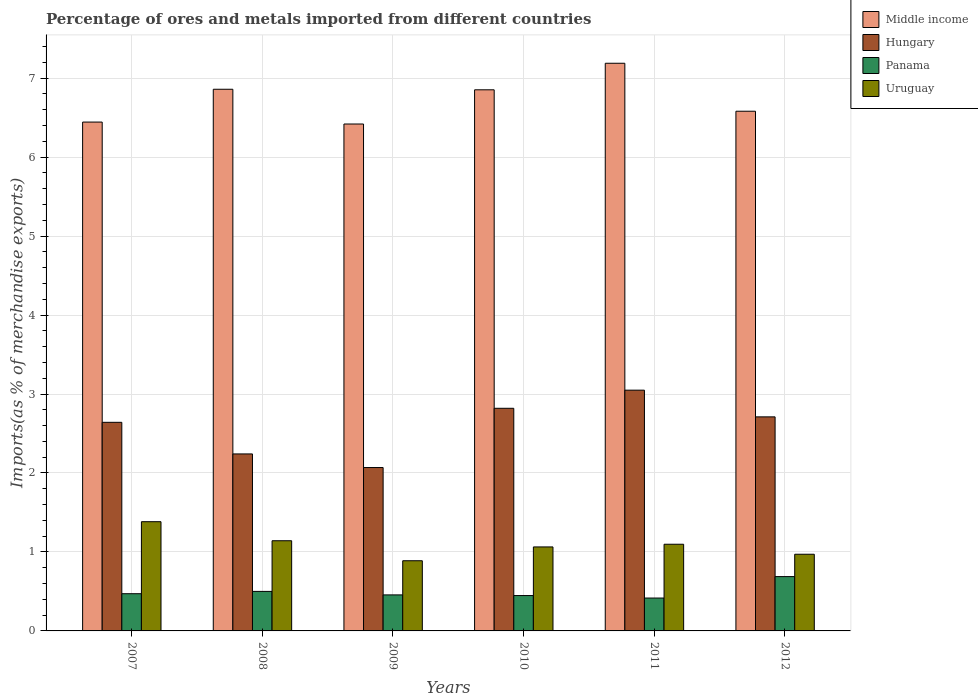Are the number of bars per tick equal to the number of legend labels?
Make the answer very short. Yes. How many bars are there on the 6th tick from the left?
Give a very brief answer. 4. What is the label of the 1st group of bars from the left?
Make the answer very short. 2007. In how many cases, is the number of bars for a given year not equal to the number of legend labels?
Ensure brevity in your answer.  0. What is the percentage of imports to different countries in Middle income in 2007?
Ensure brevity in your answer.  6.44. Across all years, what is the maximum percentage of imports to different countries in Hungary?
Provide a short and direct response. 3.05. Across all years, what is the minimum percentage of imports to different countries in Hungary?
Give a very brief answer. 2.07. In which year was the percentage of imports to different countries in Uruguay minimum?
Offer a terse response. 2009. What is the total percentage of imports to different countries in Hungary in the graph?
Your answer should be very brief. 15.53. What is the difference between the percentage of imports to different countries in Uruguay in 2008 and that in 2011?
Keep it short and to the point. 0.04. What is the difference between the percentage of imports to different countries in Panama in 2008 and the percentage of imports to different countries in Uruguay in 2012?
Provide a short and direct response. -0.47. What is the average percentage of imports to different countries in Panama per year?
Your answer should be compact. 0.5. In the year 2009, what is the difference between the percentage of imports to different countries in Middle income and percentage of imports to different countries in Uruguay?
Ensure brevity in your answer.  5.53. What is the ratio of the percentage of imports to different countries in Middle income in 2007 to that in 2010?
Your answer should be very brief. 0.94. Is the percentage of imports to different countries in Middle income in 2007 less than that in 2008?
Provide a succinct answer. Yes. What is the difference between the highest and the second highest percentage of imports to different countries in Panama?
Make the answer very short. 0.19. What is the difference between the highest and the lowest percentage of imports to different countries in Uruguay?
Provide a short and direct response. 0.49. Is the sum of the percentage of imports to different countries in Middle income in 2008 and 2009 greater than the maximum percentage of imports to different countries in Hungary across all years?
Your answer should be compact. Yes. Where does the legend appear in the graph?
Offer a terse response. Top right. What is the title of the graph?
Ensure brevity in your answer.  Percentage of ores and metals imported from different countries. What is the label or title of the X-axis?
Your response must be concise. Years. What is the label or title of the Y-axis?
Provide a short and direct response. Imports(as % of merchandise exports). What is the Imports(as % of merchandise exports) in Middle income in 2007?
Provide a succinct answer. 6.44. What is the Imports(as % of merchandise exports) in Hungary in 2007?
Offer a terse response. 2.64. What is the Imports(as % of merchandise exports) in Panama in 2007?
Provide a short and direct response. 0.47. What is the Imports(as % of merchandise exports) in Uruguay in 2007?
Offer a very short reply. 1.38. What is the Imports(as % of merchandise exports) in Middle income in 2008?
Your answer should be very brief. 6.86. What is the Imports(as % of merchandise exports) of Hungary in 2008?
Your response must be concise. 2.24. What is the Imports(as % of merchandise exports) in Panama in 2008?
Your answer should be very brief. 0.5. What is the Imports(as % of merchandise exports) of Uruguay in 2008?
Make the answer very short. 1.14. What is the Imports(as % of merchandise exports) of Middle income in 2009?
Give a very brief answer. 6.42. What is the Imports(as % of merchandise exports) of Hungary in 2009?
Your answer should be compact. 2.07. What is the Imports(as % of merchandise exports) in Panama in 2009?
Give a very brief answer. 0.46. What is the Imports(as % of merchandise exports) of Uruguay in 2009?
Your answer should be very brief. 0.89. What is the Imports(as % of merchandise exports) in Middle income in 2010?
Make the answer very short. 6.85. What is the Imports(as % of merchandise exports) of Hungary in 2010?
Your answer should be compact. 2.82. What is the Imports(as % of merchandise exports) in Panama in 2010?
Give a very brief answer. 0.45. What is the Imports(as % of merchandise exports) of Uruguay in 2010?
Give a very brief answer. 1.06. What is the Imports(as % of merchandise exports) in Middle income in 2011?
Give a very brief answer. 7.19. What is the Imports(as % of merchandise exports) of Hungary in 2011?
Make the answer very short. 3.05. What is the Imports(as % of merchandise exports) of Panama in 2011?
Provide a short and direct response. 0.42. What is the Imports(as % of merchandise exports) in Uruguay in 2011?
Give a very brief answer. 1.1. What is the Imports(as % of merchandise exports) of Middle income in 2012?
Offer a terse response. 6.58. What is the Imports(as % of merchandise exports) in Hungary in 2012?
Ensure brevity in your answer.  2.71. What is the Imports(as % of merchandise exports) of Panama in 2012?
Your response must be concise. 0.69. What is the Imports(as % of merchandise exports) of Uruguay in 2012?
Keep it short and to the point. 0.97. Across all years, what is the maximum Imports(as % of merchandise exports) in Middle income?
Your answer should be compact. 7.19. Across all years, what is the maximum Imports(as % of merchandise exports) of Hungary?
Give a very brief answer. 3.05. Across all years, what is the maximum Imports(as % of merchandise exports) in Panama?
Ensure brevity in your answer.  0.69. Across all years, what is the maximum Imports(as % of merchandise exports) of Uruguay?
Ensure brevity in your answer.  1.38. Across all years, what is the minimum Imports(as % of merchandise exports) of Middle income?
Provide a succinct answer. 6.42. Across all years, what is the minimum Imports(as % of merchandise exports) of Hungary?
Your answer should be very brief. 2.07. Across all years, what is the minimum Imports(as % of merchandise exports) of Panama?
Offer a terse response. 0.42. Across all years, what is the minimum Imports(as % of merchandise exports) in Uruguay?
Your answer should be compact. 0.89. What is the total Imports(as % of merchandise exports) of Middle income in the graph?
Keep it short and to the point. 40.34. What is the total Imports(as % of merchandise exports) of Hungary in the graph?
Give a very brief answer. 15.53. What is the total Imports(as % of merchandise exports) in Panama in the graph?
Your answer should be compact. 2.98. What is the total Imports(as % of merchandise exports) of Uruguay in the graph?
Make the answer very short. 6.55. What is the difference between the Imports(as % of merchandise exports) of Middle income in 2007 and that in 2008?
Keep it short and to the point. -0.42. What is the difference between the Imports(as % of merchandise exports) of Hungary in 2007 and that in 2008?
Give a very brief answer. 0.4. What is the difference between the Imports(as % of merchandise exports) in Panama in 2007 and that in 2008?
Offer a terse response. -0.03. What is the difference between the Imports(as % of merchandise exports) of Uruguay in 2007 and that in 2008?
Provide a succinct answer. 0.24. What is the difference between the Imports(as % of merchandise exports) of Middle income in 2007 and that in 2009?
Your answer should be very brief. 0.02. What is the difference between the Imports(as % of merchandise exports) of Hungary in 2007 and that in 2009?
Give a very brief answer. 0.57. What is the difference between the Imports(as % of merchandise exports) in Panama in 2007 and that in 2009?
Keep it short and to the point. 0.01. What is the difference between the Imports(as % of merchandise exports) of Uruguay in 2007 and that in 2009?
Your answer should be very brief. 0.49. What is the difference between the Imports(as % of merchandise exports) of Middle income in 2007 and that in 2010?
Provide a short and direct response. -0.41. What is the difference between the Imports(as % of merchandise exports) in Hungary in 2007 and that in 2010?
Give a very brief answer. -0.18. What is the difference between the Imports(as % of merchandise exports) of Panama in 2007 and that in 2010?
Your answer should be very brief. 0.02. What is the difference between the Imports(as % of merchandise exports) in Uruguay in 2007 and that in 2010?
Make the answer very short. 0.32. What is the difference between the Imports(as % of merchandise exports) in Middle income in 2007 and that in 2011?
Provide a short and direct response. -0.74. What is the difference between the Imports(as % of merchandise exports) of Hungary in 2007 and that in 2011?
Your answer should be compact. -0.41. What is the difference between the Imports(as % of merchandise exports) of Panama in 2007 and that in 2011?
Ensure brevity in your answer.  0.05. What is the difference between the Imports(as % of merchandise exports) in Uruguay in 2007 and that in 2011?
Give a very brief answer. 0.29. What is the difference between the Imports(as % of merchandise exports) of Middle income in 2007 and that in 2012?
Your response must be concise. -0.14. What is the difference between the Imports(as % of merchandise exports) in Hungary in 2007 and that in 2012?
Provide a short and direct response. -0.07. What is the difference between the Imports(as % of merchandise exports) in Panama in 2007 and that in 2012?
Your response must be concise. -0.22. What is the difference between the Imports(as % of merchandise exports) of Uruguay in 2007 and that in 2012?
Your answer should be very brief. 0.41. What is the difference between the Imports(as % of merchandise exports) in Middle income in 2008 and that in 2009?
Offer a terse response. 0.44. What is the difference between the Imports(as % of merchandise exports) in Hungary in 2008 and that in 2009?
Make the answer very short. 0.17. What is the difference between the Imports(as % of merchandise exports) of Panama in 2008 and that in 2009?
Give a very brief answer. 0.04. What is the difference between the Imports(as % of merchandise exports) in Uruguay in 2008 and that in 2009?
Keep it short and to the point. 0.25. What is the difference between the Imports(as % of merchandise exports) of Middle income in 2008 and that in 2010?
Your response must be concise. 0.01. What is the difference between the Imports(as % of merchandise exports) in Hungary in 2008 and that in 2010?
Give a very brief answer. -0.58. What is the difference between the Imports(as % of merchandise exports) in Panama in 2008 and that in 2010?
Provide a short and direct response. 0.05. What is the difference between the Imports(as % of merchandise exports) in Uruguay in 2008 and that in 2010?
Provide a short and direct response. 0.08. What is the difference between the Imports(as % of merchandise exports) in Middle income in 2008 and that in 2011?
Your answer should be very brief. -0.33. What is the difference between the Imports(as % of merchandise exports) in Hungary in 2008 and that in 2011?
Your answer should be compact. -0.81. What is the difference between the Imports(as % of merchandise exports) of Panama in 2008 and that in 2011?
Ensure brevity in your answer.  0.08. What is the difference between the Imports(as % of merchandise exports) of Uruguay in 2008 and that in 2011?
Give a very brief answer. 0.04. What is the difference between the Imports(as % of merchandise exports) in Middle income in 2008 and that in 2012?
Provide a short and direct response. 0.28. What is the difference between the Imports(as % of merchandise exports) of Hungary in 2008 and that in 2012?
Offer a terse response. -0.47. What is the difference between the Imports(as % of merchandise exports) in Panama in 2008 and that in 2012?
Make the answer very short. -0.19. What is the difference between the Imports(as % of merchandise exports) of Uruguay in 2008 and that in 2012?
Offer a terse response. 0.17. What is the difference between the Imports(as % of merchandise exports) in Middle income in 2009 and that in 2010?
Offer a terse response. -0.43. What is the difference between the Imports(as % of merchandise exports) of Hungary in 2009 and that in 2010?
Offer a very short reply. -0.75. What is the difference between the Imports(as % of merchandise exports) in Panama in 2009 and that in 2010?
Ensure brevity in your answer.  0.01. What is the difference between the Imports(as % of merchandise exports) of Uruguay in 2009 and that in 2010?
Give a very brief answer. -0.17. What is the difference between the Imports(as % of merchandise exports) of Middle income in 2009 and that in 2011?
Keep it short and to the point. -0.77. What is the difference between the Imports(as % of merchandise exports) of Hungary in 2009 and that in 2011?
Make the answer very short. -0.98. What is the difference between the Imports(as % of merchandise exports) in Panama in 2009 and that in 2011?
Provide a succinct answer. 0.04. What is the difference between the Imports(as % of merchandise exports) of Uruguay in 2009 and that in 2011?
Your response must be concise. -0.21. What is the difference between the Imports(as % of merchandise exports) of Middle income in 2009 and that in 2012?
Give a very brief answer. -0.16. What is the difference between the Imports(as % of merchandise exports) in Hungary in 2009 and that in 2012?
Offer a terse response. -0.64. What is the difference between the Imports(as % of merchandise exports) in Panama in 2009 and that in 2012?
Make the answer very short. -0.23. What is the difference between the Imports(as % of merchandise exports) in Uruguay in 2009 and that in 2012?
Ensure brevity in your answer.  -0.08. What is the difference between the Imports(as % of merchandise exports) in Middle income in 2010 and that in 2011?
Your answer should be compact. -0.34. What is the difference between the Imports(as % of merchandise exports) of Hungary in 2010 and that in 2011?
Keep it short and to the point. -0.23. What is the difference between the Imports(as % of merchandise exports) in Panama in 2010 and that in 2011?
Keep it short and to the point. 0.03. What is the difference between the Imports(as % of merchandise exports) in Uruguay in 2010 and that in 2011?
Give a very brief answer. -0.03. What is the difference between the Imports(as % of merchandise exports) of Middle income in 2010 and that in 2012?
Your answer should be compact. 0.27. What is the difference between the Imports(as % of merchandise exports) in Hungary in 2010 and that in 2012?
Your response must be concise. 0.11. What is the difference between the Imports(as % of merchandise exports) in Panama in 2010 and that in 2012?
Your response must be concise. -0.24. What is the difference between the Imports(as % of merchandise exports) of Uruguay in 2010 and that in 2012?
Ensure brevity in your answer.  0.09. What is the difference between the Imports(as % of merchandise exports) of Middle income in 2011 and that in 2012?
Ensure brevity in your answer.  0.61. What is the difference between the Imports(as % of merchandise exports) in Hungary in 2011 and that in 2012?
Provide a short and direct response. 0.34. What is the difference between the Imports(as % of merchandise exports) of Panama in 2011 and that in 2012?
Your answer should be compact. -0.27. What is the difference between the Imports(as % of merchandise exports) of Uruguay in 2011 and that in 2012?
Offer a very short reply. 0.13. What is the difference between the Imports(as % of merchandise exports) in Middle income in 2007 and the Imports(as % of merchandise exports) in Hungary in 2008?
Make the answer very short. 4.2. What is the difference between the Imports(as % of merchandise exports) in Middle income in 2007 and the Imports(as % of merchandise exports) in Panama in 2008?
Your answer should be very brief. 5.94. What is the difference between the Imports(as % of merchandise exports) of Middle income in 2007 and the Imports(as % of merchandise exports) of Uruguay in 2008?
Offer a very short reply. 5.3. What is the difference between the Imports(as % of merchandise exports) in Hungary in 2007 and the Imports(as % of merchandise exports) in Panama in 2008?
Give a very brief answer. 2.14. What is the difference between the Imports(as % of merchandise exports) of Hungary in 2007 and the Imports(as % of merchandise exports) of Uruguay in 2008?
Make the answer very short. 1.5. What is the difference between the Imports(as % of merchandise exports) of Panama in 2007 and the Imports(as % of merchandise exports) of Uruguay in 2008?
Make the answer very short. -0.67. What is the difference between the Imports(as % of merchandise exports) in Middle income in 2007 and the Imports(as % of merchandise exports) in Hungary in 2009?
Your answer should be compact. 4.37. What is the difference between the Imports(as % of merchandise exports) in Middle income in 2007 and the Imports(as % of merchandise exports) in Panama in 2009?
Provide a succinct answer. 5.99. What is the difference between the Imports(as % of merchandise exports) of Middle income in 2007 and the Imports(as % of merchandise exports) of Uruguay in 2009?
Your response must be concise. 5.55. What is the difference between the Imports(as % of merchandise exports) of Hungary in 2007 and the Imports(as % of merchandise exports) of Panama in 2009?
Your answer should be compact. 2.19. What is the difference between the Imports(as % of merchandise exports) in Hungary in 2007 and the Imports(as % of merchandise exports) in Uruguay in 2009?
Make the answer very short. 1.75. What is the difference between the Imports(as % of merchandise exports) of Panama in 2007 and the Imports(as % of merchandise exports) of Uruguay in 2009?
Ensure brevity in your answer.  -0.42. What is the difference between the Imports(as % of merchandise exports) of Middle income in 2007 and the Imports(as % of merchandise exports) of Hungary in 2010?
Provide a short and direct response. 3.62. What is the difference between the Imports(as % of merchandise exports) in Middle income in 2007 and the Imports(as % of merchandise exports) in Panama in 2010?
Your response must be concise. 6. What is the difference between the Imports(as % of merchandise exports) in Middle income in 2007 and the Imports(as % of merchandise exports) in Uruguay in 2010?
Provide a succinct answer. 5.38. What is the difference between the Imports(as % of merchandise exports) of Hungary in 2007 and the Imports(as % of merchandise exports) of Panama in 2010?
Offer a very short reply. 2.19. What is the difference between the Imports(as % of merchandise exports) of Hungary in 2007 and the Imports(as % of merchandise exports) of Uruguay in 2010?
Provide a succinct answer. 1.58. What is the difference between the Imports(as % of merchandise exports) of Panama in 2007 and the Imports(as % of merchandise exports) of Uruguay in 2010?
Your answer should be very brief. -0.59. What is the difference between the Imports(as % of merchandise exports) in Middle income in 2007 and the Imports(as % of merchandise exports) in Hungary in 2011?
Provide a short and direct response. 3.39. What is the difference between the Imports(as % of merchandise exports) of Middle income in 2007 and the Imports(as % of merchandise exports) of Panama in 2011?
Provide a short and direct response. 6.03. What is the difference between the Imports(as % of merchandise exports) in Middle income in 2007 and the Imports(as % of merchandise exports) in Uruguay in 2011?
Your response must be concise. 5.35. What is the difference between the Imports(as % of merchandise exports) in Hungary in 2007 and the Imports(as % of merchandise exports) in Panama in 2011?
Keep it short and to the point. 2.23. What is the difference between the Imports(as % of merchandise exports) in Hungary in 2007 and the Imports(as % of merchandise exports) in Uruguay in 2011?
Your answer should be very brief. 1.54. What is the difference between the Imports(as % of merchandise exports) of Panama in 2007 and the Imports(as % of merchandise exports) of Uruguay in 2011?
Your response must be concise. -0.63. What is the difference between the Imports(as % of merchandise exports) in Middle income in 2007 and the Imports(as % of merchandise exports) in Hungary in 2012?
Make the answer very short. 3.73. What is the difference between the Imports(as % of merchandise exports) in Middle income in 2007 and the Imports(as % of merchandise exports) in Panama in 2012?
Your answer should be very brief. 5.76. What is the difference between the Imports(as % of merchandise exports) of Middle income in 2007 and the Imports(as % of merchandise exports) of Uruguay in 2012?
Your answer should be very brief. 5.47. What is the difference between the Imports(as % of merchandise exports) in Hungary in 2007 and the Imports(as % of merchandise exports) in Panama in 2012?
Give a very brief answer. 1.95. What is the difference between the Imports(as % of merchandise exports) of Hungary in 2007 and the Imports(as % of merchandise exports) of Uruguay in 2012?
Your response must be concise. 1.67. What is the difference between the Imports(as % of merchandise exports) in Panama in 2007 and the Imports(as % of merchandise exports) in Uruguay in 2012?
Make the answer very short. -0.5. What is the difference between the Imports(as % of merchandise exports) of Middle income in 2008 and the Imports(as % of merchandise exports) of Hungary in 2009?
Your answer should be compact. 4.79. What is the difference between the Imports(as % of merchandise exports) in Middle income in 2008 and the Imports(as % of merchandise exports) in Panama in 2009?
Offer a very short reply. 6.4. What is the difference between the Imports(as % of merchandise exports) of Middle income in 2008 and the Imports(as % of merchandise exports) of Uruguay in 2009?
Ensure brevity in your answer.  5.97. What is the difference between the Imports(as % of merchandise exports) of Hungary in 2008 and the Imports(as % of merchandise exports) of Panama in 2009?
Your answer should be very brief. 1.79. What is the difference between the Imports(as % of merchandise exports) of Hungary in 2008 and the Imports(as % of merchandise exports) of Uruguay in 2009?
Give a very brief answer. 1.35. What is the difference between the Imports(as % of merchandise exports) in Panama in 2008 and the Imports(as % of merchandise exports) in Uruguay in 2009?
Offer a very short reply. -0.39. What is the difference between the Imports(as % of merchandise exports) of Middle income in 2008 and the Imports(as % of merchandise exports) of Hungary in 2010?
Provide a short and direct response. 4.04. What is the difference between the Imports(as % of merchandise exports) in Middle income in 2008 and the Imports(as % of merchandise exports) in Panama in 2010?
Your answer should be very brief. 6.41. What is the difference between the Imports(as % of merchandise exports) of Middle income in 2008 and the Imports(as % of merchandise exports) of Uruguay in 2010?
Provide a succinct answer. 5.8. What is the difference between the Imports(as % of merchandise exports) of Hungary in 2008 and the Imports(as % of merchandise exports) of Panama in 2010?
Make the answer very short. 1.79. What is the difference between the Imports(as % of merchandise exports) in Hungary in 2008 and the Imports(as % of merchandise exports) in Uruguay in 2010?
Offer a very short reply. 1.18. What is the difference between the Imports(as % of merchandise exports) in Panama in 2008 and the Imports(as % of merchandise exports) in Uruguay in 2010?
Offer a very short reply. -0.56. What is the difference between the Imports(as % of merchandise exports) in Middle income in 2008 and the Imports(as % of merchandise exports) in Hungary in 2011?
Offer a very short reply. 3.81. What is the difference between the Imports(as % of merchandise exports) in Middle income in 2008 and the Imports(as % of merchandise exports) in Panama in 2011?
Offer a very short reply. 6.44. What is the difference between the Imports(as % of merchandise exports) of Middle income in 2008 and the Imports(as % of merchandise exports) of Uruguay in 2011?
Keep it short and to the point. 5.76. What is the difference between the Imports(as % of merchandise exports) of Hungary in 2008 and the Imports(as % of merchandise exports) of Panama in 2011?
Make the answer very short. 1.82. What is the difference between the Imports(as % of merchandise exports) in Hungary in 2008 and the Imports(as % of merchandise exports) in Uruguay in 2011?
Give a very brief answer. 1.14. What is the difference between the Imports(as % of merchandise exports) of Panama in 2008 and the Imports(as % of merchandise exports) of Uruguay in 2011?
Make the answer very short. -0.6. What is the difference between the Imports(as % of merchandise exports) in Middle income in 2008 and the Imports(as % of merchandise exports) in Hungary in 2012?
Ensure brevity in your answer.  4.15. What is the difference between the Imports(as % of merchandise exports) of Middle income in 2008 and the Imports(as % of merchandise exports) of Panama in 2012?
Offer a terse response. 6.17. What is the difference between the Imports(as % of merchandise exports) of Middle income in 2008 and the Imports(as % of merchandise exports) of Uruguay in 2012?
Ensure brevity in your answer.  5.89. What is the difference between the Imports(as % of merchandise exports) of Hungary in 2008 and the Imports(as % of merchandise exports) of Panama in 2012?
Keep it short and to the point. 1.55. What is the difference between the Imports(as % of merchandise exports) in Hungary in 2008 and the Imports(as % of merchandise exports) in Uruguay in 2012?
Make the answer very short. 1.27. What is the difference between the Imports(as % of merchandise exports) in Panama in 2008 and the Imports(as % of merchandise exports) in Uruguay in 2012?
Offer a very short reply. -0.47. What is the difference between the Imports(as % of merchandise exports) in Middle income in 2009 and the Imports(as % of merchandise exports) in Hungary in 2010?
Ensure brevity in your answer.  3.6. What is the difference between the Imports(as % of merchandise exports) in Middle income in 2009 and the Imports(as % of merchandise exports) in Panama in 2010?
Give a very brief answer. 5.97. What is the difference between the Imports(as % of merchandise exports) in Middle income in 2009 and the Imports(as % of merchandise exports) in Uruguay in 2010?
Your answer should be compact. 5.36. What is the difference between the Imports(as % of merchandise exports) in Hungary in 2009 and the Imports(as % of merchandise exports) in Panama in 2010?
Offer a very short reply. 1.62. What is the difference between the Imports(as % of merchandise exports) of Hungary in 2009 and the Imports(as % of merchandise exports) of Uruguay in 2010?
Give a very brief answer. 1.01. What is the difference between the Imports(as % of merchandise exports) of Panama in 2009 and the Imports(as % of merchandise exports) of Uruguay in 2010?
Offer a very short reply. -0.61. What is the difference between the Imports(as % of merchandise exports) of Middle income in 2009 and the Imports(as % of merchandise exports) of Hungary in 2011?
Offer a very short reply. 3.37. What is the difference between the Imports(as % of merchandise exports) of Middle income in 2009 and the Imports(as % of merchandise exports) of Panama in 2011?
Ensure brevity in your answer.  6. What is the difference between the Imports(as % of merchandise exports) of Middle income in 2009 and the Imports(as % of merchandise exports) of Uruguay in 2011?
Make the answer very short. 5.32. What is the difference between the Imports(as % of merchandise exports) in Hungary in 2009 and the Imports(as % of merchandise exports) in Panama in 2011?
Keep it short and to the point. 1.65. What is the difference between the Imports(as % of merchandise exports) in Hungary in 2009 and the Imports(as % of merchandise exports) in Uruguay in 2011?
Offer a terse response. 0.97. What is the difference between the Imports(as % of merchandise exports) of Panama in 2009 and the Imports(as % of merchandise exports) of Uruguay in 2011?
Ensure brevity in your answer.  -0.64. What is the difference between the Imports(as % of merchandise exports) of Middle income in 2009 and the Imports(as % of merchandise exports) of Hungary in 2012?
Give a very brief answer. 3.71. What is the difference between the Imports(as % of merchandise exports) in Middle income in 2009 and the Imports(as % of merchandise exports) in Panama in 2012?
Give a very brief answer. 5.73. What is the difference between the Imports(as % of merchandise exports) in Middle income in 2009 and the Imports(as % of merchandise exports) in Uruguay in 2012?
Your response must be concise. 5.45. What is the difference between the Imports(as % of merchandise exports) in Hungary in 2009 and the Imports(as % of merchandise exports) in Panama in 2012?
Your answer should be very brief. 1.38. What is the difference between the Imports(as % of merchandise exports) in Hungary in 2009 and the Imports(as % of merchandise exports) in Uruguay in 2012?
Provide a short and direct response. 1.1. What is the difference between the Imports(as % of merchandise exports) of Panama in 2009 and the Imports(as % of merchandise exports) of Uruguay in 2012?
Keep it short and to the point. -0.51. What is the difference between the Imports(as % of merchandise exports) of Middle income in 2010 and the Imports(as % of merchandise exports) of Hungary in 2011?
Keep it short and to the point. 3.8. What is the difference between the Imports(as % of merchandise exports) of Middle income in 2010 and the Imports(as % of merchandise exports) of Panama in 2011?
Provide a short and direct response. 6.44. What is the difference between the Imports(as % of merchandise exports) in Middle income in 2010 and the Imports(as % of merchandise exports) in Uruguay in 2011?
Make the answer very short. 5.75. What is the difference between the Imports(as % of merchandise exports) of Hungary in 2010 and the Imports(as % of merchandise exports) of Panama in 2011?
Your answer should be very brief. 2.4. What is the difference between the Imports(as % of merchandise exports) of Hungary in 2010 and the Imports(as % of merchandise exports) of Uruguay in 2011?
Your answer should be very brief. 1.72. What is the difference between the Imports(as % of merchandise exports) in Panama in 2010 and the Imports(as % of merchandise exports) in Uruguay in 2011?
Your answer should be very brief. -0.65. What is the difference between the Imports(as % of merchandise exports) in Middle income in 2010 and the Imports(as % of merchandise exports) in Hungary in 2012?
Ensure brevity in your answer.  4.14. What is the difference between the Imports(as % of merchandise exports) of Middle income in 2010 and the Imports(as % of merchandise exports) of Panama in 2012?
Offer a very short reply. 6.16. What is the difference between the Imports(as % of merchandise exports) in Middle income in 2010 and the Imports(as % of merchandise exports) in Uruguay in 2012?
Offer a terse response. 5.88. What is the difference between the Imports(as % of merchandise exports) of Hungary in 2010 and the Imports(as % of merchandise exports) of Panama in 2012?
Your response must be concise. 2.13. What is the difference between the Imports(as % of merchandise exports) of Hungary in 2010 and the Imports(as % of merchandise exports) of Uruguay in 2012?
Offer a terse response. 1.85. What is the difference between the Imports(as % of merchandise exports) of Panama in 2010 and the Imports(as % of merchandise exports) of Uruguay in 2012?
Provide a succinct answer. -0.52. What is the difference between the Imports(as % of merchandise exports) of Middle income in 2011 and the Imports(as % of merchandise exports) of Hungary in 2012?
Provide a short and direct response. 4.48. What is the difference between the Imports(as % of merchandise exports) of Middle income in 2011 and the Imports(as % of merchandise exports) of Panama in 2012?
Ensure brevity in your answer.  6.5. What is the difference between the Imports(as % of merchandise exports) of Middle income in 2011 and the Imports(as % of merchandise exports) of Uruguay in 2012?
Ensure brevity in your answer.  6.22. What is the difference between the Imports(as % of merchandise exports) of Hungary in 2011 and the Imports(as % of merchandise exports) of Panama in 2012?
Your answer should be compact. 2.36. What is the difference between the Imports(as % of merchandise exports) in Hungary in 2011 and the Imports(as % of merchandise exports) in Uruguay in 2012?
Provide a succinct answer. 2.08. What is the difference between the Imports(as % of merchandise exports) of Panama in 2011 and the Imports(as % of merchandise exports) of Uruguay in 2012?
Keep it short and to the point. -0.55. What is the average Imports(as % of merchandise exports) in Middle income per year?
Provide a succinct answer. 6.72. What is the average Imports(as % of merchandise exports) in Hungary per year?
Your answer should be very brief. 2.59. What is the average Imports(as % of merchandise exports) of Panama per year?
Provide a succinct answer. 0.5. What is the average Imports(as % of merchandise exports) of Uruguay per year?
Provide a short and direct response. 1.09. In the year 2007, what is the difference between the Imports(as % of merchandise exports) of Middle income and Imports(as % of merchandise exports) of Hungary?
Keep it short and to the point. 3.8. In the year 2007, what is the difference between the Imports(as % of merchandise exports) in Middle income and Imports(as % of merchandise exports) in Panama?
Make the answer very short. 5.97. In the year 2007, what is the difference between the Imports(as % of merchandise exports) in Middle income and Imports(as % of merchandise exports) in Uruguay?
Offer a very short reply. 5.06. In the year 2007, what is the difference between the Imports(as % of merchandise exports) in Hungary and Imports(as % of merchandise exports) in Panama?
Make the answer very short. 2.17. In the year 2007, what is the difference between the Imports(as % of merchandise exports) in Hungary and Imports(as % of merchandise exports) in Uruguay?
Offer a very short reply. 1.26. In the year 2007, what is the difference between the Imports(as % of merchandise exports) of Panama and Imports(as % of merchandise exports) of Uruguay?
Keep it short and to the point. -0.91. In the year 2008, what is the difference between the Imports(as % of merchandise exports) of Middle income and Imports(as % of merchandise exports) of Hungary?
Provide a succinct answer. 4.62. In the year 2008, what is the difference between the Imports(as % of merchandise exports) of Middle income and Imports(as % of merchandise exports) of Panama?
Ensure brevity in your answer.  6.36. In the year 2008, what is the difference between the Imports(as % of merchandise exports) in Middle income and Imports(as % of merchandise exports) in Uruguay?
Ensure brevity in your answer.  5.72. In the year 2008, what is the difference between the Imports(as % of merchandise exports) of Hungary and Imports(as % of merchandise exports) of Panama?
Offer a very short reply. 1.74. In the year 2008, what is the difference between the Imports(as % of merchandise exports) in Hungary and Imports(as % of merchandise exports) in Uruguay?
Your response must be concise. 1.1. In the year 2008, what is the difference between the Imports(as % of merchandise exports) of Panama and Imports(as % of merchandise exports) of Uruguay?
Your response must be concise. -0.64. In the year 2009, what is the difference between the Imports(as % of merchandise exports) of Middle income and Imports(as % of merchandise exports) of Hungary?
Provide a succinct answer. 4.35. In the year 2009, what is the difference between the Imports(as % of merchandise exports) of Middle income and Imports(as % of merchandise exports) of Panama?
Provide a short and direct response. 5.96. In the year 2009, what is the difference between the Imports(as % of merchandise exports) of Middle income and Imports(as % of merchandise exports) of Uruguay?
Your answer should be very brief. 5.53. In the year 2009, what is the difference between the Imports(as % of merchandise exports) of Hungary and Imports(as % of merchandise exports) of Panama?
Give a very brief answer. 1.61. In the year 2009, what is the difference between the Imports(as % of merchandise exports) of Hungary and Imports(as % of merchandise exports) of Uruguay?
Make the answer very short. 1.18. In the year 2009, what is the difference between the Imports(as % of merchandise exports) in Panama and Imports(as % of merchandise exports) in Uruguay?
Give a very brief answer. -0.43. In the year 2010, what is the difference between the Imports(as % of merchandise exports) of Middle income and Imports(as % of merchandise exports) of Hungary?
Your answer should be compact. 4.03. In the year 2010, what is the difference between the Imports(as % of merchandise exports) of Middle income and Imports(as % of merchandise exports) of Panama?
Your answer should be very brief. 6.4. In the year 2010, what is the difference between the Imports(as % of merchandise exports) of Middle income and Imports(as % of merchandise exports) of Uruguay?
Provide a short and direct response. 5.79. In the year 2010, what is the difference between the Imports(as % of merchandise exports) in Hungary and Imports(as % of merchandise exports) in Panama?
Make the answer very short. 2.37. In the year 2010, what is the difference between the Imports(as % of merchandise exports) in Hungary and Imports(as % of merchandise exports) in Uruguay?
Ensure brevity in your answer.  1.76. In the year 2010, what is the difference between the Imports(as % of merchandise exports) of Panama and Imports(as % of merchandise exports) of Uruguay?
Offer a very short reply. -0.62. In the year 2011, what is the difference between the Imports(as % of merchandise exports) in Middle income and Imports(as % of merchandise exports) in Hungary?
Offer a very short reply. 4.14. In the year 2011, what is the difference between the Imports(as % of merchandise exports) in Middle income and Imports(as % of merchandise exports) in Panama?
Ensure brevity in your answer.  6.77. In the year 2011, what is the difference between the Imports(as % of merchandise exports) of Middle income and Imports(as % of merchandise exports) of Uruguay?
Keep it short and to the point. 6.09. In the year 2011, what is the difference between the Imports(as % of merchandise exports) in Hungary and Imports(as % of merchandise exports) in Panama?
Provide a short and direct response. 2.63. In the year 2011, what is the difference between the Imports(as % of merchandise exports) in Hungary and Imports(as % of merchandise exports) in Uruguay?
Provide a short and direct response. 1.95. In the year 2011, what is the difference between the Imports(as % of merchandise exports) in Panama and Imports(as % of merchandise exports) in Uruguay?
Provide a short and direct response. -0.68. In the year 2012, what is the difference between the Imports(as % of merchandise exports) of Middle income and Imports(as % of merchandise exports) of Hungary?
Give a very brief answer. 3.87. In the year 2012, what is the difference between the Imports(as % of merchandise exports) of Middle income and Imports(as % of merchandise exports) of Panama?
Offer a terse response. 5.89. In the year 2012, what is the difference between the Imports(as % of merchandise exports) in Middle income and Imports(as % of merchandise exports) in Uruguay?
Your answer should be very brief. 5.61. In the year 2012, what is the difference between the Imports(as % of merchandise exports) of Hungary and Imports(as % of merchandise exports) of Panama?
Offer a very short reply. 2.02. In the year 2012, what is the difference between the Imports(as % of merchandise exports) of Hungary and Imports(as % of merchandise exports) of Uruguay?
Provide a short and direct response. 1.74. In the year 2012, what is the difference between the Imports(as % of merchandise exports) of Panama and Imports(as % of merchandise exports) of Uruguay?
Make the answer very short. -0.28. What is the ratio of the Imports(as % of merchandise exports) of Middle income in 2007 to that in 2008?
Your answer should be compact. 0.94. What is the ratio of the Imports(as % of merchandise exports) of Hungary in 2007 to that in 2008?
Keep it short and to the point. 1.18. What is the ratio of the Imports(as % of merchandise exports) of Uruguay in 2007 to that in 2008?
Offer a terse response. 1.21. What is the ratio of the Imports(as % of merchandise exports) of Middle income in 2007 to that in 2009?
Your answer should be compact. 1. What is the ratio of the Imports(as % of merchandise exports) of Hungary in 2007 to that in 2009?
Your answer should be very brief. 1.28. What is the ratio of the Imports(as % of merchandise exports) of Panama in 2007 to that in 2009?
Your answer should be very brief. 1.03. What is the ratio of the Imports(as % of merchandise exports) of Uruguay in 2007 to that in 2009?
Offer a terse response. 1.56. What is the ratio of the Imports(as % of merchandise exports) in Middle income in 2007 to that in 2010?
Your answer should be compact. 0.94. What is the ratio of the Imports(as % of merchandise exports) in Hungary in 2007 to that in 2010?
Keep it short and to the point. 0.94. What is the ratio of the Imports(as % of merchandise exports) in Panama in 2007 to that in 2010?
Make the answer very short. 1.05. What is the ratio of the Imports(as % of merchandise exports) in Uruguay in 2007 to that in 2010?
Provide a succinct answer. 1.3. What is the ratio of the Imports(as % of merchandise exports) of Middle income in 2007 to that in 2011?
Offer a terse response. 0.9. What is the ratio of the Imports(as % of merchandise exports) in Hungary in 2007 to that in 2011?
Offer a very short reply. 0.87. What is the ratio of the Imports(as % of merchandise exports) of Panama in 2007 to that in 2011?
Make the answer very short. 1.13. What is the ratio of the Imports(as % of merchandise exports) in Uruguay in 2007 to that in 2011?
Make the answer very short. 1.26. What is the ratio of the Imports(as % of merchandise exports) of Middle income in 2007 to that in 2012?
Your answer should be compact. 0.98. What is the ratio of the Imports(as % of merchandise exports) in Hungary in 2007 to that in 2012?
Give a very brief answer. 0.97. What is the ratio of the Imports(as % of merchandise exports) in Panama in 2007 to that in 2012?
Keep it short and to the point. 0.68. What is the ratio of the Imports(as % of merchandise exports) in Uruguay in 2007 to that in 2012?
Ensure brevity in your answer.  1.42. What is the ratio of the Imports(as % of merchandise exports) of Middle income in 2008 to that in 2009?
Ensure brevity in your answer.  1.07. What is the ratio of the Imports(as % of merchandise exports) in Panama in 2008 to that in 2009?
Keep it short and to the point. 1.1. What is the ratio of the Imports(as % of merchandise exports) in Uruguay in 2008 to that in 2009?
Your answer should be very brief. 1.28. What is the ratio of the Imports(as % of merchandise exports) of Hungary in 2008 to that in 2010?
Offer a terse response. 0.8. What is the ratio of the Imports(as % of merchandise exports) in Panama in 2008 to that in 2010?
Keep it short and to the point. 1.12. What is the ratio of the Imports(as % of merchandise exports) in Uruguay in 2008 to that in 2010?
Your answer should be compact. 1.07. What is the ratio of the Imports(as % of merchandise exports) in Middle income in 2008 to that in 2011?
Give a very brief answer. 0.95. What is the ratio of the Imports(as % of merchandise exports) in Hungary in 2008 to that in 2011?
Your answer should be very brief. 0.74. What is the ratio of the Imports(as % of merchandise exports) in Panama in 2008 to that in 2011?
Ensure brevity in your answer.  1.2. What is the ratio of the Imports(as % of merchandise exports) in Uruguay in 2008 to that in 2011?
Your answer should be compact. 1.04. What is the ratio of the Imports(as % of merchandise exports) in Middle income in 2008 to that in 2012?
Your response must be concise. 1.04. What is the ratio of the Imports(as % of merchandise exports) in Hungary in 2008 to that in 2012?
Your answer should be very brief. 0.83. What is the ratio of the Imports(as % of merchandise exports) in Panama in 2008 to that in 2012?
Your response must be concise. 0.73. What is the ratio of the Imports(as % of merchandise exports) in Uruguay in 2008 to that in 2012?
Offer a terse response. 1.18. What is the ratio of the Imports(as % of merchandise exports) of Middle income in 2009 to that in 2010?
Your answer should be very brief. 0.94. What is the ratio of the Imports(as % of merchandise exports) in Hungary in 2009 to that in 2010?
Your response must be concise. 0.73. What is the ratio of the Imports(as % of merchandise exports) of Panama in 2009 to that in 2010?
Make the answer very short. 1.02. What is the ratio of the Imports(as % of merchandise exports) of Uruguay in 2009 to that in 2010?
Offer a terse response. 0.84. What is the ratio of the Imports(as % of merchandise exports) of Middle income in 2009 to that in 2011?
Offer a very short reply. 0.89. What is the ratio of the Imports(as % of merchandise exports) of Hungary in 2009 to that in 2011?
Your answer should be compact. 0.68. What is the ratio of the Imports(as % of merchandise exports) in Panama in 2009 to that in 2011?
Ensure brevity in your answer.  1.1. What is the ratio of the Imports(as % of merchandise exports) in Uruguay in 2009 to that in 2011?
Offer a very short reply. 0.81. What is the ratio of the Imports(as % of merchandise exports) in Middle income in 2009 to that in 2012?
Ensure brevity in your answer.  0.98. What is the ratio of the Imports(as % of merchandise exports) in Hungary in 2009 to that in 2012?
Your answer should be very brief. 0.76. What is the ratio of the Imports(as % of merchandise exports) in Panama in 2009 to that in 2012?
Your answer should be compact. 0.66. What is the ratio of the Imports(as % of merchandise exports) of Uruguay in 2009 to that in 2012?
Keep it short and to the point. 0.92. What is the ratio of the Imports(as % of merchandise exports) in Middle income in 2010 to that in 2011?
Your answer should be compact. 0.95. What is the ratio of the Imports(as % of merchandise exports) of Hungary in 2010 to that in 2011?
Your response must be concise. 0.92. What is the ratio of the Imports(as % of merchandise exports) of Panama in 2010 to that in 2011?
Provide a succinct answer. 1.08. What is the ratio of the Imports(as % of merchandise exports) of Uruguay in 2010 to that in 2011?
Give a very brief answer. 0.97. What is the ratio of the Imports(as % of merchandise exports) in Middle income in 2010 to that in 2012?
Your response must be concise. 1.04. What is the ratio of the Imports(as % of merchandise exports) in Hungary in 2010 to that in 2012?
Your answer should be compact. 1.04. What is the ratio of the Imports(as % of merchandise exports) of Panama in 2010 to that in 2012?
Ensure brevity in your answer.  0.65. What is the ratio of the Imports(as % of merchandise exports) of Uruguay in 2010 to that in 2012?
Your response must be concise. 1.1. What is the ratio of the Imports(as % of merchandise exports) of Middle income in 2011 to that in 2012?
Ensure brevity in your answer.  1.09. What is the ratio of the Imports(as % of merchandise exports) in Hungary in 2011 to that in 2012?
Your response must be concise. 1.12. What is the ratio of the Imports(as % of merchandise exports) of Panama in 2011 to that in 2012?
Keep it short and to the point. 0.61. What is the ratio of the Imports(as % of merchandise exports) in Uruguay in 2011 to that in 2012?
Provide a short and direct response. 1.13. What is the difference between the highest and the second highest Imports(as % of merchandise exports) in Middle income?
Ensure brevity in your answer.  0.33. What is the difference between the highest and the second highest Imports(as % of merchandise exports) in Hungary?
Your response must be concise. 0.23. What is the difference between the highest and the second highest Imports(as % of merchandise exports) in Panama?
Ensure brevity in your answer.  0.19. What is the difference between the highest and the second highest Imports(as % of merchandise exports) of Uruguay?
Your answer should be compact. 0.24. What is the difference between the highest and the lowest Imports(as % of merchandise exports) in Middle income?
Give a very brief answer. 0.77. What is the difference between the highest and the lowest Imports(as % of merchandise exports) in Hungary?
Provide a succinct answer. 0.98. What is the difference between the highest and the lowest Imports(as % of merchandise exports) of Panama?
Your response must be concise. 0.27. What is the difference between the highest and the lowest Imports(as % of merchandise exports) in Uruguay?
Keep it short and to the point. 0.49. 